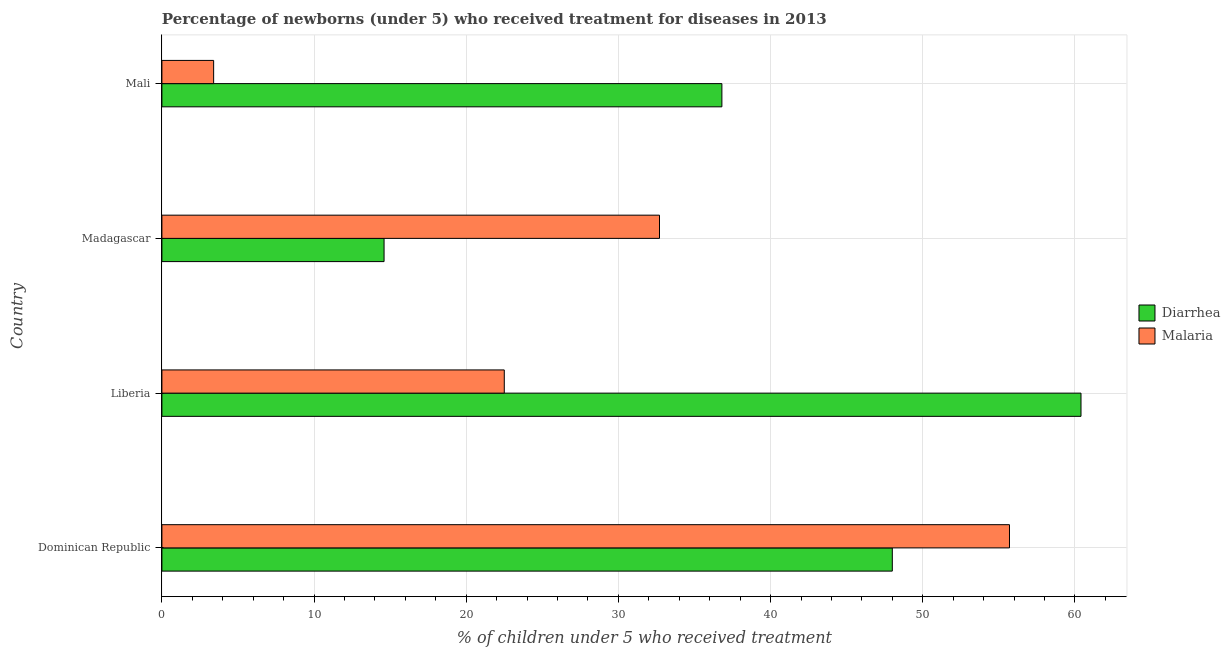How many different coloured bars are there?
Offer a very short reply. 2. How many bars are there on the 1st tick from the top?
Offer a terse response. 2. What is the label of the 3rd group of bars from the top?
Your answer should be very brief. Liberia. What is the percentage of children who received treatment for diarrhoea in Mali?
Your answer should be compact. 36.8. Across all countries, what is the maximum percentage of children who received treatment for malaria?
Ensure brevity in your answer.  55.7. Across all countries, what is the minimum percentage of children who received treatment for malaria?
Keep it short and to the point. 3.4. In which country was the percentage of children who received treatment for malaria maximum?
Give a very brief answer. Dominican Republic. In which country was the percentage of children who received treatment for malaria minimum?
Ensure brevity in your answer.  Mali. What is the total percentage of children who received treatment for diarrhoea in the graph?
Ensure brevity in your answer.  159.8. What is the difference between the percentage of children who received treatment for diarrhoea in Liberia and that in Mali?
Provide a short and direct response. 23.6. What is the difference between the percentage of children who received treatment for malaria in Madagascar and the percentage of children who received treatment for diarrhoea in Liberia?
Give a very brief answer. -27.7. What is the average percentage of children who received treatment for diarrhoea per country?
Give a very brief answer. 39.95. What is the difference between the percentage of children who received treatment for malaria and percentage of children who received treatment for diarrhoea in Madagascar?
Make the answer very short. 18.1. In how many countries, is the percentage of children who received treatment for malaria greater than 52 %?
Provide a succinct answer. 1. What is the ratio of the percentage of children who received treatment for malaria in Dominican Republic to that in Madagascar?
Make the answer very short. 1.7. Is the percentage of children who received treatment for malaria in Dominican Republic less than that in Liberia?
Provide a succinct answer. No. Is the difference between the percentage of children who received treatment for malaria in Liberia and Madagascar greater than the difference between the percentage of children who received treatment for diarrhoea in Liberia and Madagascar?
Make the answer very short. No. What is the difference between the highest and the second highest percentage of children who received treatment for malaria?
Provide a short and direct response. 23. What is the difference between the highest and the lowest percentage of children who received treatment for diarrhoea?
Your answer should be compact. 45.8. What does the 1st bar from the top in Liberia represents?
Give a very brief answer. Malaria. What does the 2nd bar from the bottom in Mali represents?
Make the answer very short. Malaria. What is the difference between two consecutive major ticks on the X-axis?
Your answer should be compact. 10. Does the graph contain any zero values?
Give a very brief answer. No. What is the title of the graph?
Your answer should be compact. Percentage of newborns (under 5) who received treatment for diseases in 2013. What is the label or title of the X-axis?
Your answer should be very brief. % of children under 5 who received treatment. What is the % of children under 5 who received treatment of Diarrhea in Dominican Republic?
Provide a succinct answer. 48. What is the % of children under 5 who received treatment of Malaria in Dominican Republic?
Give a very brief answer. 55.7. What is the % of children under 5 who received treatment of Diarrhea in Liberia?
Provide a short and direct response. 60.4. What is the % of children under 5 who received treatment of Malaria in Liberia?
Offer a very short reply. 22.5. What is the % of children under 5 who received treatment in Malaria in Madagascar?
Provide a short and direct response. 32.7. What is the % of children under 5 who received treatment of Diarrhea in Mali?
Give a very brief answer. 36.8. Across all countries, what is the maximum % of children under 5 who received treatment in Diarrhea?
Keep it short and to the point. 60.4. Across all countries, what is the maximum % of children under 5 who received treatment of Malaria?
Your response must be concise. 55.7. Across all countries, what is the minimum % of children under 5 who received treatment of Diarrhea?
Keep it short and to the point. 14.6. What is the total % of children under 5 who received treatment of Diarrhea in the graph?
Make the answer very short. 159.8. What is the total % of children under 5 who received treatment of Malaria in the graph?
Provide a succinct answer. 114.3. What is the difference between the % of children under 5 who received treatment of Diarrhea in Dominican Republic and that in Liberia?
Keep it short and to the point. -12.4. What is the difference between the % of children under 5 who received treatment of Malaria in Dominican Republic and that in Liberia?
Provide a succinct answer. 33.2. What is the difference between the % of children under 5 who received treatment of Diarrhea in Dominican Republic and that in Madagascar?
Your answer should be very brief. 33.4. What is the difference between the % of children under 5 who received treatment in Malaria in Dominican Republic and that in Madagascar?
Ensure brevity in your answer.  23. What is the difference between the % of children under 5 who received treatment of Malaria in Dominican Republic and that in Mali?
Your answer should be very brief. 52.3. What is the difference between the % of children under 5 who received treatment in Diarrhea in Liberia and that in Madagascar?
Make the answer very short. 45.8. What is the difference between the % of children under 5 who received treatment of Diarrhea in Liberia and that in Mali?
Ensure brevity in your answer.  23.6. What is the difference between the % of children under 5 who received treatment in Diarrhea in Madagascar and that in Mali?
Ensure brevity in your answer.  -22.2. What is the difference between the % of children under 5 who received treatment of Malaria in Madagascar and that in Mali?
Keep it short and to the point. 29.3. What is the difference between the % of children under 5 who received treatment of Diarrhea in Dominican Republic and the % of children under 5 who received treatment of Malaria in Mali?
Ensure brevity in your answer.  44.6. What is the difference between the % of children under 5 who received treatment of Diarrhea in Liberia and the % of children under 5 who received treatment of Malaria in Madagascar?
Provide a short and direct response. 27.7. What is the difference between the % of children under 5 who received treatment of Diarrhea in Madagascar and the % of children under 5 who received treatment of Malaria in Mali?
Ensure brevity in your answer.  11.2. What is the average % of children under 5 who received treatment of Diarrhea per country?
Your answer should be compact. 39.95. What is the average % of children under 5 who received treatment of Malaria per country?
Provide a short and direct response. 28.57. What is the difference between the % of children under 5 who received treatment in Diarrhea and % of children under 5 who received treatment in Malaria in Liberia?
Ensure brevity in your answer.  37.9. What is the difference between the % of children under 5 who received treatment in Diarrhea and % of children under 5 who received treatment in Malaria in Madagascar?
Give a very brief answer. -18.1. What is the difference between the % of children under 5 who received treatment in Diarrhea and % of children under 5 who received treatment in Malaria in Mali?
Keep it short and to the point. 33.4. What is the ratio of the % of children under 5 who received treatment of Diarrhea in Dominican Republic to that in Liberia?
Make the answer very short. 0.79. What is the ratio of the % of children under 5 who received treatment in Malaria in Dominican Republic to that in Liberia?
Keep it short and to the point. 2.48. What is the ratio of the % of children under 5 who received treatment of Diarrhea in Dominican Republic to that in Madagascar?
Ensure brevity in your answer.  3.29. What is the ratio of the % of children under 5 who received treatment in Malaria in Dominican Republic to that in Madagascar?
Offer a terse response. 1.7. What is the ratio of the % of children under 5 who received treatment in Diarrhea in Dominican Republic to that in Mali?
Give a very brief answer. 1.3. What is the ratio of the % of children under 5 who received treatment in Malaria in Dominican Republic to that in Mali?
Your answer should be compact. 16.38. What is the ratio of the % of children under 5 who received treatment in Diarrhea in Liberia to that in Madagascar?
Offer a terse response. 4.14. What is the ratio of the % of children under 5 who received treatment of Malaria in Liberia to that in Madagascar?
Provide a succinct answer. 0.69. What is the ratio of the % of children under 5 who received treatment of Diarrhea in Liberia to that in Mali?
Make the answer very short. 1.64. What is the ratio of the % of children under 5 who received treatment of Malaria in Liberia to that in Mali?
Make the answer very short. 6.62. What is the ratio of the % of children under 5 who received treatment in Diarrhea in Madagascar to that in Mali?
Your answer should be compact. 0.4. What is the ratio of the % of children under 5 who received treatment in Malaria in Madagascar to that in Mali?
Offer a very short reply. 9.62. What is the difference between the highest and the second highest % of children under 5 who received treatment in Diarrhea?
Your answer should be compact. 12.4. What is the difference between the highest and the second highest % of children under 5 who received treatment of Malaria?
Offer a very short reply. 23. What is the difference between the highest and the lowest % of children under 5 who received treatment in Diarrhea?
Your answer should be very brief. 45.8. What is the difference between the highest and the lowest % of children under 5 who received treatment of Malaria?
Make the answer very short. 52.3. 